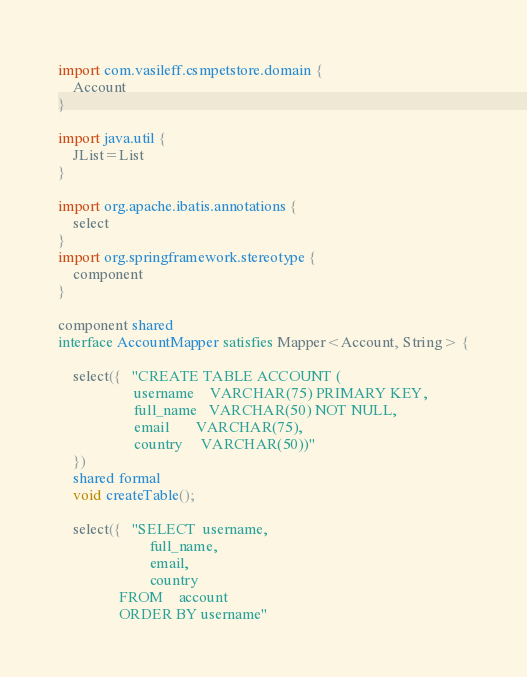Convert code to text. <code><loc_0><loc_0><loc_500><loc_500><_Ceylon_>import com.vasileff.csmpetstore.domain {
    Account
}

import java.util {
    JList=List
}

import org.apache.ibatis.annotations {
    select
}
import org.springframework.stereotype {
    component
}

component shared
interface AccountMapper satisfies Mapper<Account, String> {

    select({   "CREATE TABLE ACCOUNT (
                    username    VARCHAR(75) PRIMARY KEY,
                    full_name   VARCHAR(50) NOT NULL,
                    email       VARCHAR(75),
                    country     VARCHAR(50))"
    })
    shared formal
    void createTable();

    select({   "SELECT  username,
                        full_name,
                        email,
                        country
                FROM    account
                ORDER BY username"</code> 